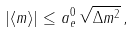Convert formula to latex. <formula><loc_0><loc_0><loc_500><loc_500>| \langle { m } \rangle | \leq a _ { e } ^ { 0 } \, \sqrt { \Delta { m } ^ { 2 } } \, ,</formula> 